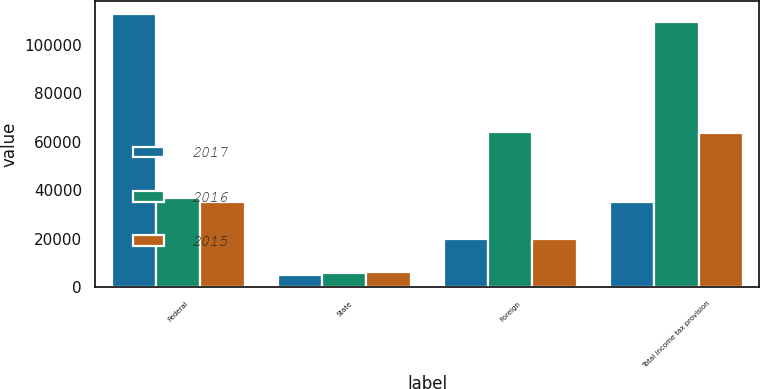Convert chart to OTSL. <chart><loc_0><loc_0><loc_500><loc_500><stacked_bar_chart><ecel><fcel>Federal<fcel>State<fcel>Foreign<fcel>Total income tax provision<nl><fcel>2017<fcel>112673<fcel>5035<fcel>19689<fcel>35029<nl><fcel>2016<fcel>36771<fcel>5785<fcel>64109<fcel>109331<nl><fcel>2015<fcel>35029<fcel>6074<fcel>19884<fcel>63760<nl></chart> 